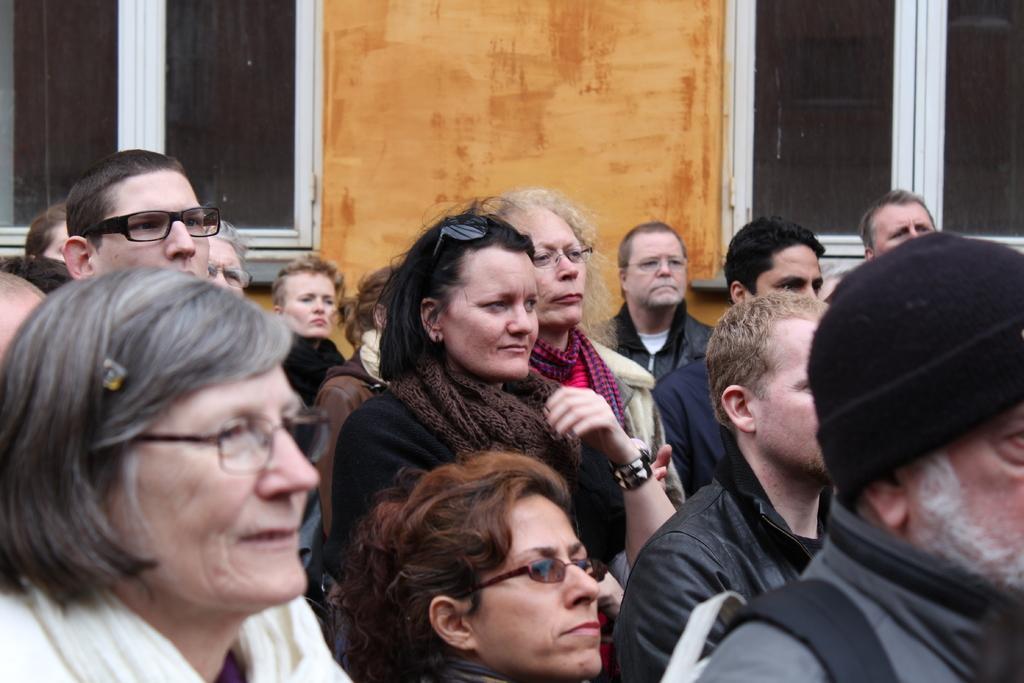Could you give a brief overview of what you see in this image? In this image we can see women and men are standing and seeing, background orange wall and glass windows are present. 